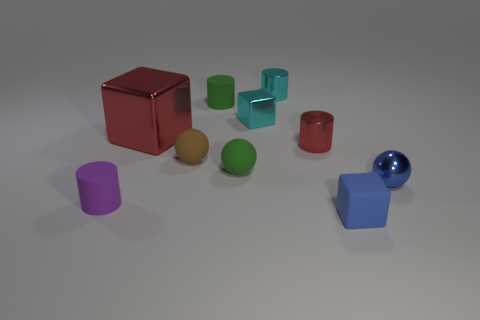Subtract all small green rubber cylinders. How many cylinders are left? 3 Subtract all red cylinders. How many cylinders are left? 3 Subtract all cylinders. How many objects are left? 6 Subtract 2 cylinders. How many cylinders are left? 2 Add 1 red matte spheres. How many red matte spheres exist? 1 Subtract 0 brown cylinders. How many objects are left? 10 Subtract all red cylinders. Subtract all cyan cubes. How many cylinders are left? 3 Subtract all blue blocks. How many cyan cylinders are left? 1 Subtract all red objects. Subtract all brown spheres. How many objects are left? 7 Add 8 blue shiny spheres. How many blue shiny spheres are left? 9 